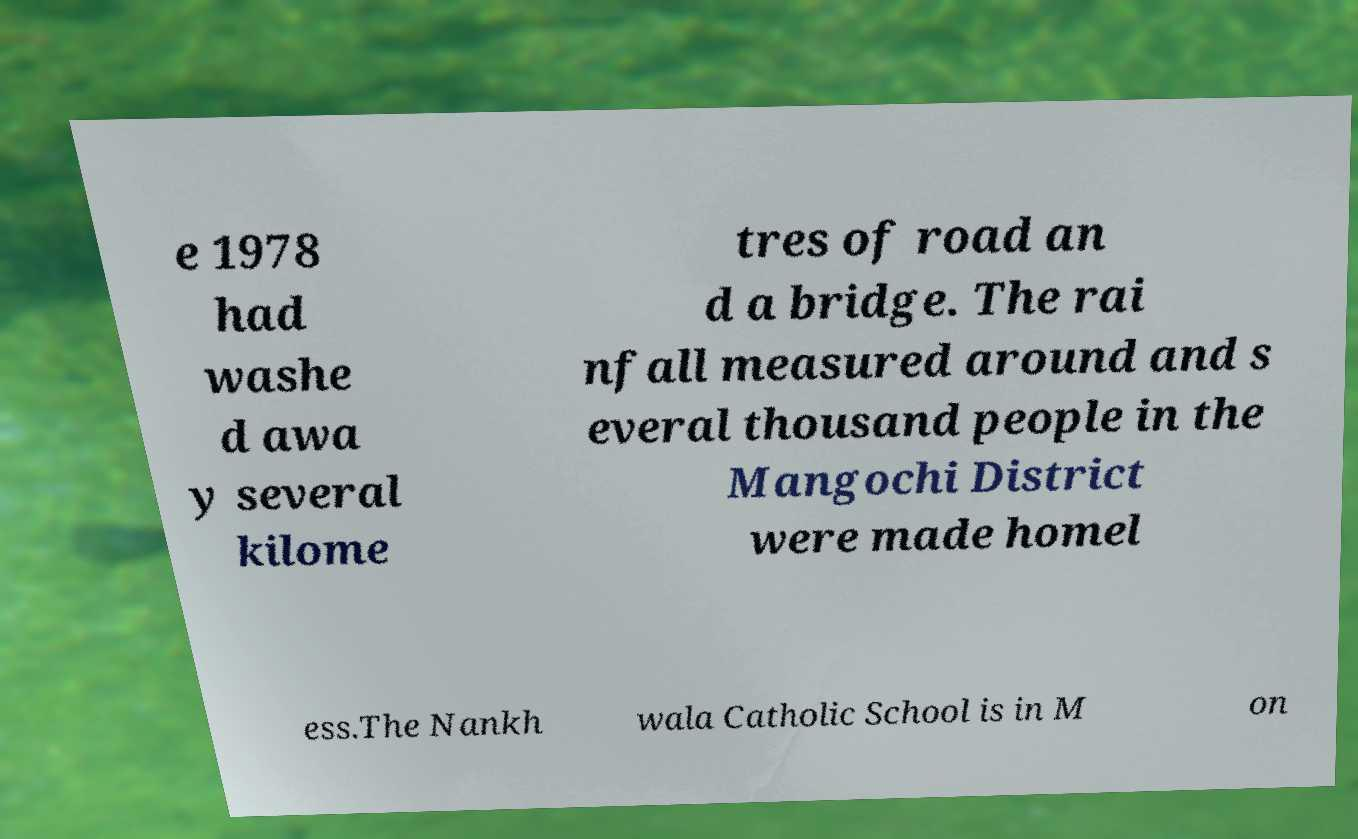For documentation purposes, I need the text within this image transcribed. Could you provide that? e 1978 had washe d awa y several kilome tres of road an d a bridge. The rai nfall measured around and s everal thousand people in the Mangochi District were made homel ess.The Nankh wala Catholic School is in M on 